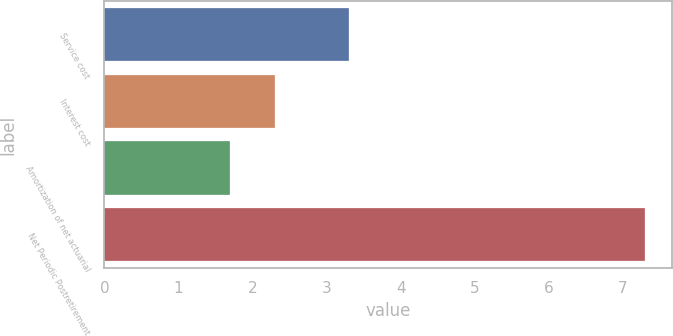<chart> <loc_0><loc_0><loc_500><loc_500><bar_chart><fcel>Service cost<fcel>Interest cost<fcel>Amortization of net actuarial<fcel>Net Periodic Postretirement<nl><fcel>3.3<fcel>2.3<fcel>1.7<fcel>7.3<nl></chart> 